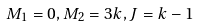Convert formula to latex. <formula><loc_0><loc_0><loc_500><loc_500>M _ { 1 } = 0 , M _ { 2 } = 3 k , J = k - 1</formula> 